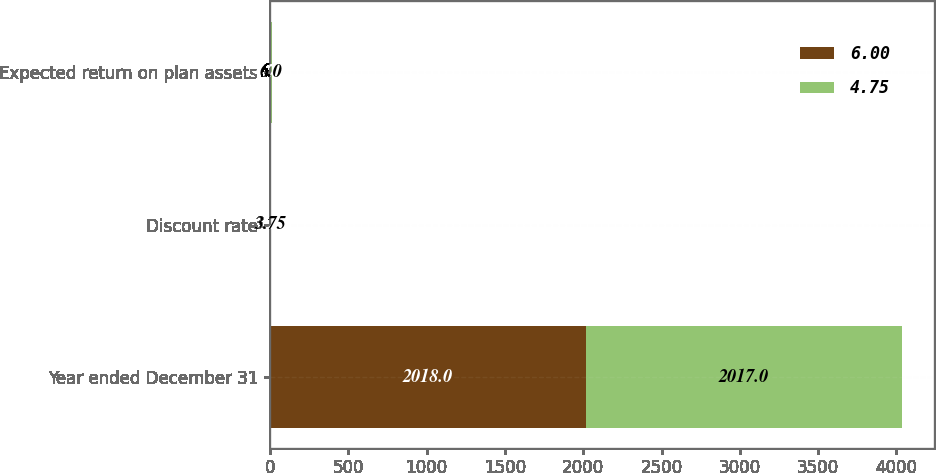Convert chart. <chart><loc_0><loc_0><loc_500><loc_500><stacked_bar_chart><ecel><fcel>Year ended December 31<fcel>Discount rate<fcel>Expected return on plan assets<nl><fcel>6<fcel>2018<fcel>3.25<fcel>4.75<nl><fcel>4.75<fcel>2017<fcel>3.75<fcel>6<nl></chart> 